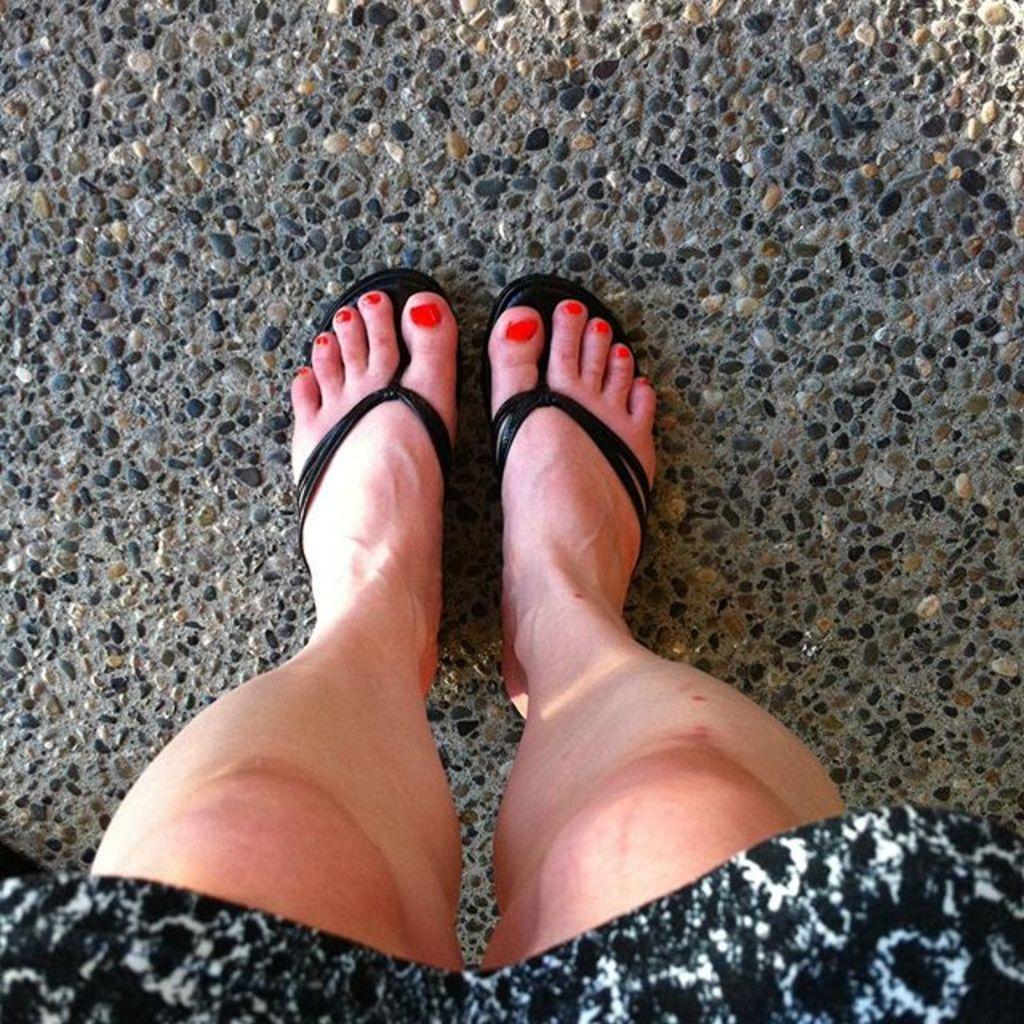In one or two sentences, can you explain what this image depicts? In this picture I can see a human legs, this person is wearing the chappals, at the bottom I can see the cloth. 